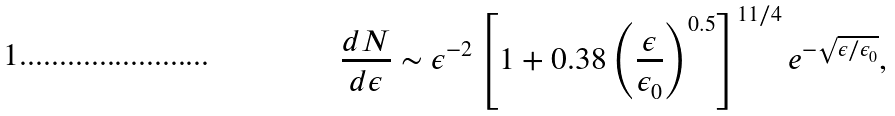Convert formula to latex. <formula><loc_0><loc_0><loc_500><loc_500>\frac { d N } { d \epsilon } \sim \epsilon ^ { - 2 } \left [ 1 + 0 . 3 8 \left ( \frac { \epsilon } { \epsilon _ { 0 } } \right ) ^ { 0 . 5 } \right ] ^ { 1 1 / 4 } e ^ { - \sqrt { \epsilon / \epsilon _ { 0 } } } ,</formula> 